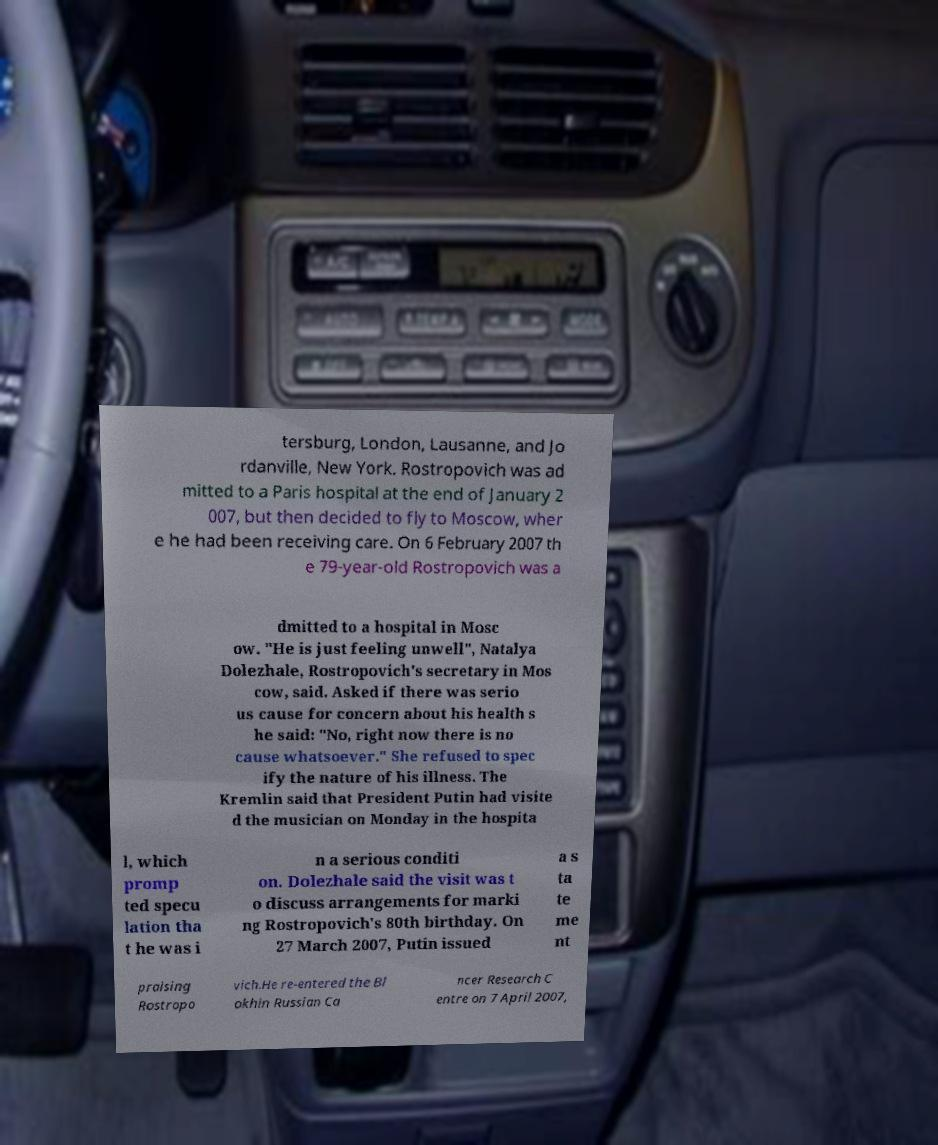Please identify and transcribe the text found in this image. tersburg, London, Lausanne, and Jo rdanville, New York. Rostropovich was ad mitted to a Paris hospital at the end of January 2 007, but then decided to fly to Moscow, wher e he had been receiving care. On 6 February 2007 th e 79-year-old Rostropovich was a dmitted to a hospital in Mosc ow. "He is just feeling unwell", Natalya Dolezhale, Rostropovich's secretary in Mos cow, said. Asked if there was serio us cause for concern about his health s he said: "No, right now there is no cause whatsoever." She refused to spec ify the nature of his illness. The Kremlin said that President Putin had visite d the musician on Monday in the hospita l, which promp ted specu lation tha t he was i n a serious conditi on. Dolezhale said the visit was t o discuss arrangements for marki ng Rostropovich's 80th birthday. On 27 March 2007, Putin issued a s ta te me nt praising Rostropo vich.He re-entered the Bl okhin Russian Ca ncer Research C entre on 7 April 2007, 